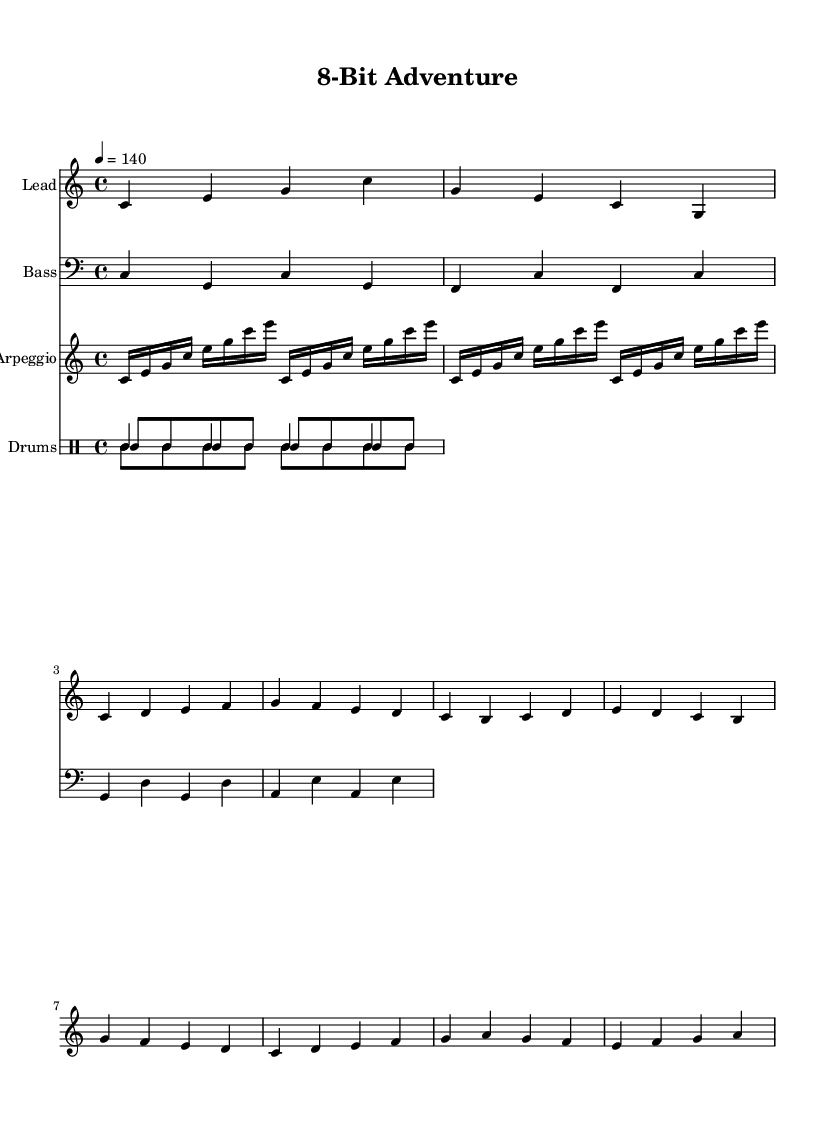What is the key signature of this music? The key signature found in the music, indicated by the key command in the global section, is C major, which has no sharps or flats.
Answer: C major What is the time signature of this music? The time signature is specified in the global section of the score and indicates how many beats are in each measure and which note value is equivalent to a beat; it is written as 4/4.
Answer: 4/4 What is the tempo marking of this music? The tempo marking is shown in the global section and indicates the speed of the music; in this case, it is set to quarter note equals 140 beats per minute.
Answer: 140 How many measures are in the lead melody? To find the number of measures in the lead melody, we can count the groups of notes separated by vertical lines (measure bars); there are 8 measures in total.
Answer: 8 What is the primary instrument shown in the score? By examining the individual staves, the first staff is labeled "Lead," which indicates that it is the primary instrument playing the lead melody in the piece.
Answer: Lead How many different percussion instruments are indicated in the drum part? The drum part lists three types of percussion, as indicated by the drumStyleTable: kick drum, snare, and hi-hat, showing the diversity in percussion used in this track.
Answer: Three What kind of musical pattern is used for the bass line? The bass line is characterized by a straightforward progression of root notes, which is typical in electronic music to provide a harmonic foundation; in this score, it follows a simple, repetitive pattern.
Answer: Simple 